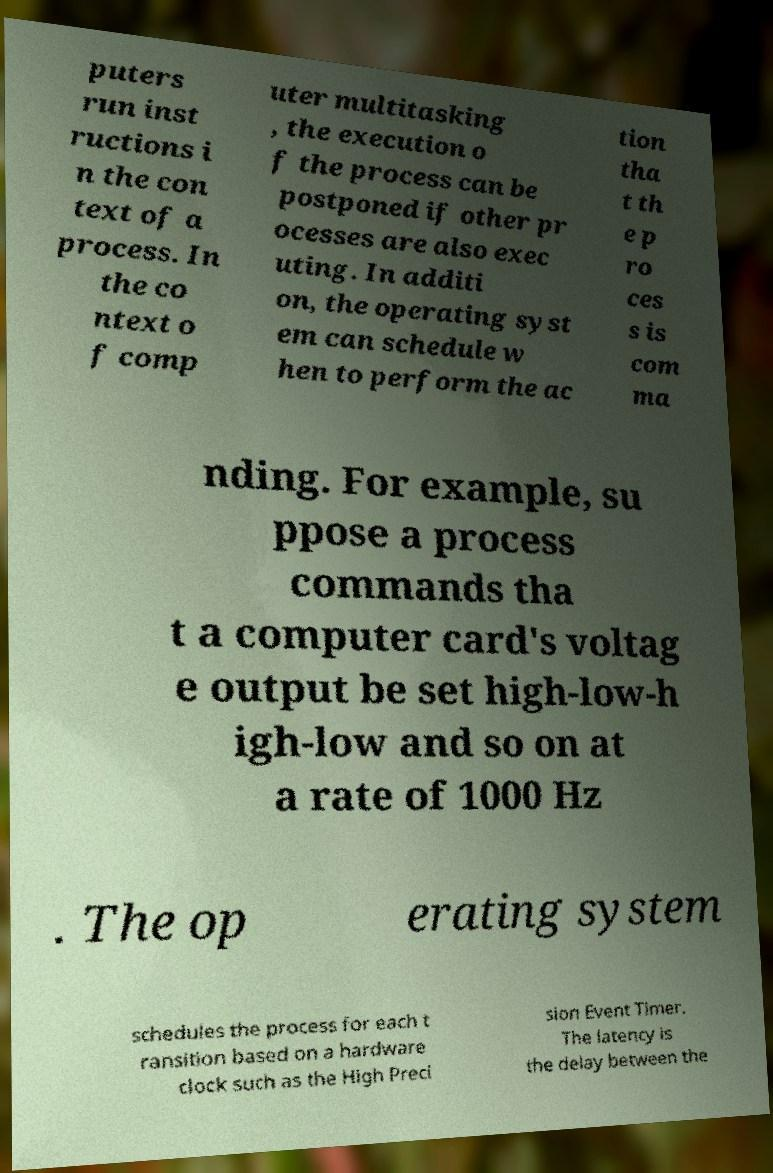Could you extract and type out the text from this image? puters run inst ructions i n the con text of a process. In the co ntext o f comp uter multitasking , the execution o f the process can be postponed if other pr ocesses are also exec uting. In additi on, the operating syst em can schedule w hen to perform the ac tion tha t th e p ro ces s is com ma nding. For example, su ppose a process commands tha t a computer card's voltag e output be set high-low-h igh-low and so on at a rate of 1000 Hz . The op erating system schedules the process for each t ransition based on a hardware clock such as the High Preci sion Event Timer. The latency is the delay between the 